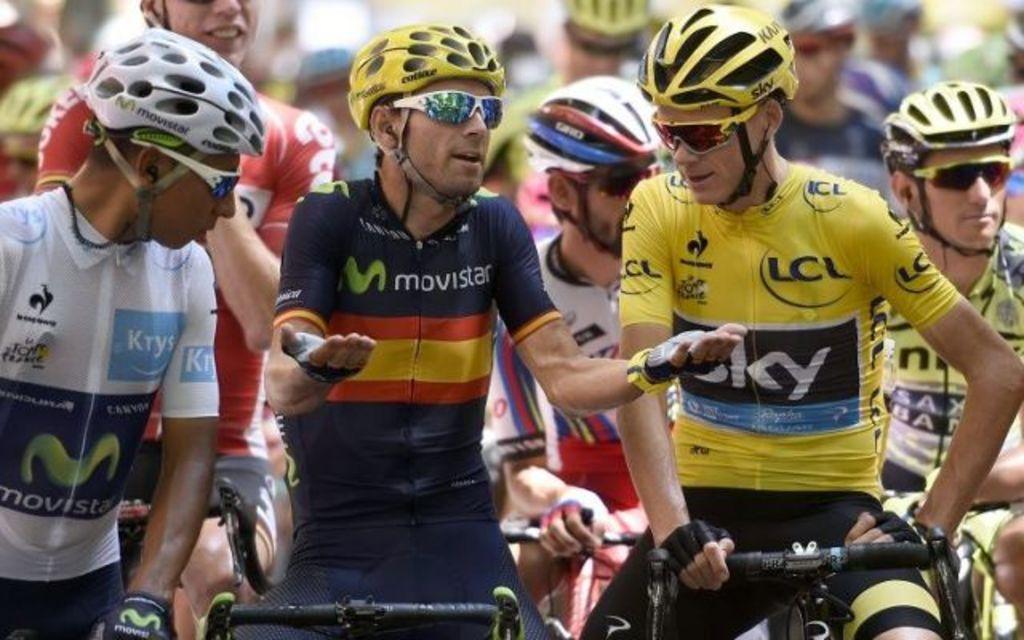Please provide a concise description of this image. In this picture I can see few people on the bicycles and they wore helmets on their heads and few of them wore sunglasses. 